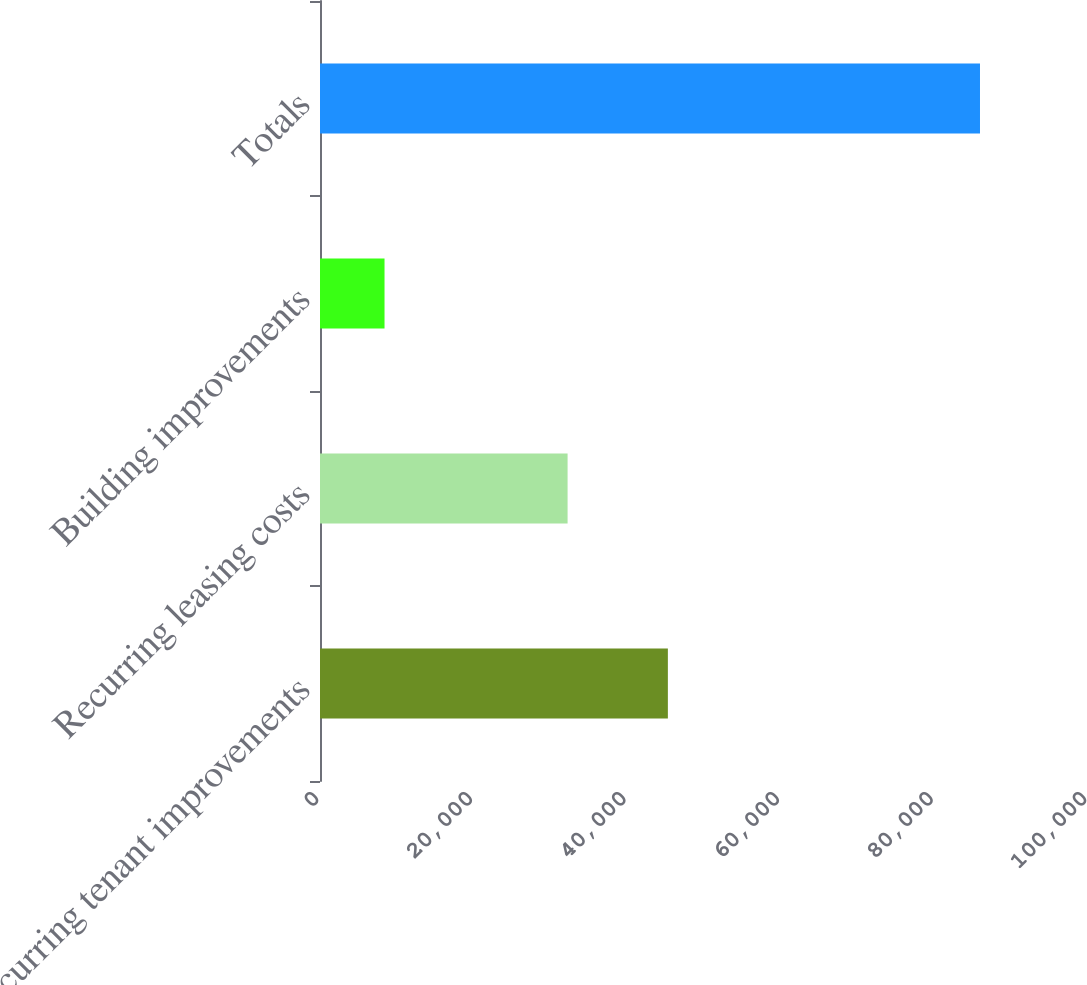Convert chart. <chart><loc_0><loc_0><loc_500><loc_500><bar_chart><fcel>Recurring tenant improvements<fcel>Recurring leasing costs<fcel>Building improvements<fcel>Totals<nl><fcel>45296<fcel>32238<fcel>8402<fcel>85936<nl></chart> 